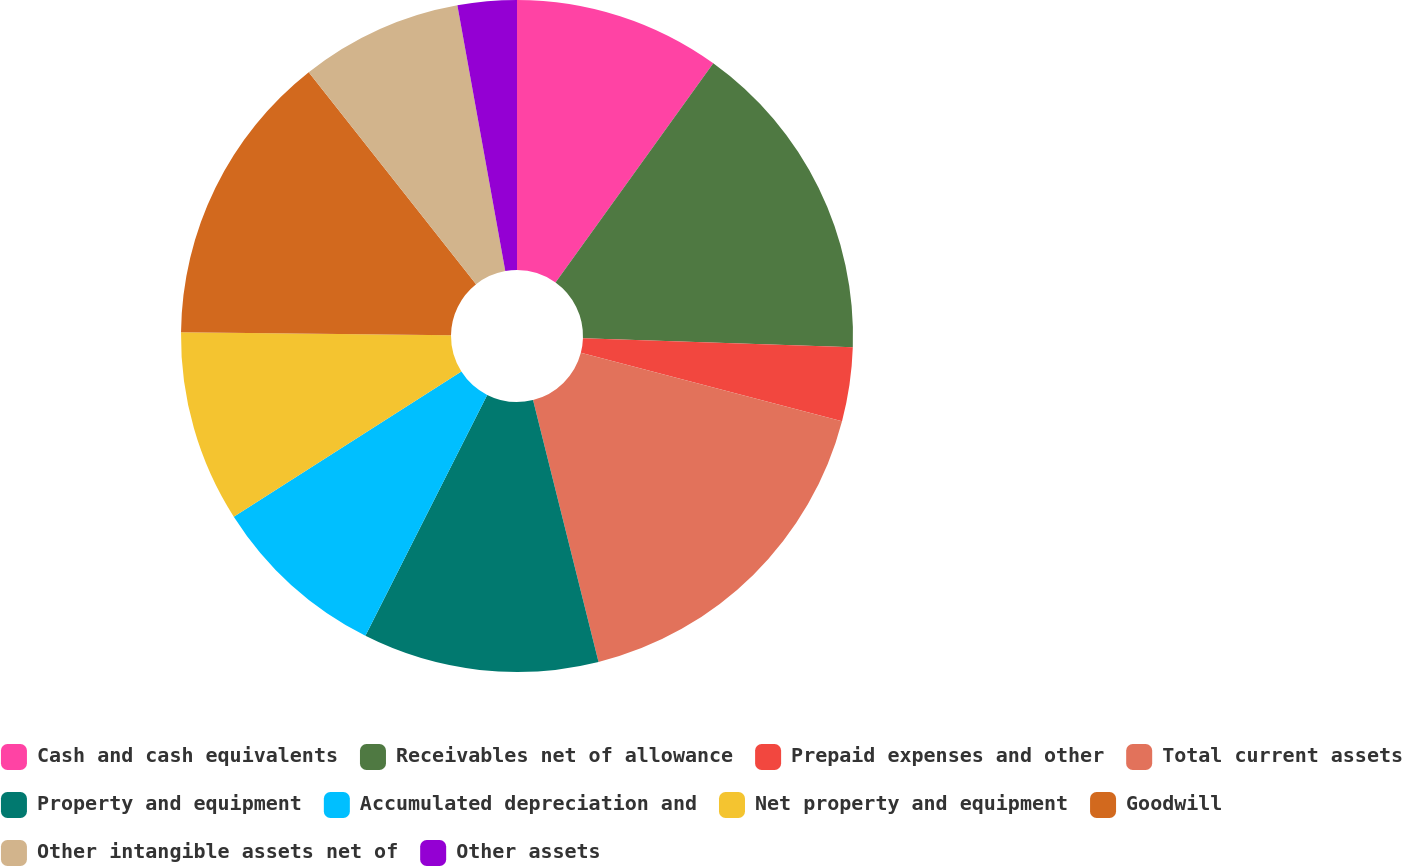Convert chart to OTSL. <chart><loc_0><loc_0><loc_500><loc_500><pie_chart><fcel>Cash and cash equivalents<fcel>Receivables net of allowance<fcel>Prepaid expenses and other<fcel>Total current assets<fcel>Property and equipment<fcel>Accumulated depreciation and<fcel>Net property and equipment<fcel>Goodwill<fcel>Other intangible assets net of<fcel>Other assets<nl><fcel>9.93%<fcel>15.6%<fcel>3.55%<fcel>17.02%<fcel>11.35%<fcel>8.51%<fcel>9.22%<fcel>14.18%<fcel>7.8%<fcel>2.84%<nl></chart> 